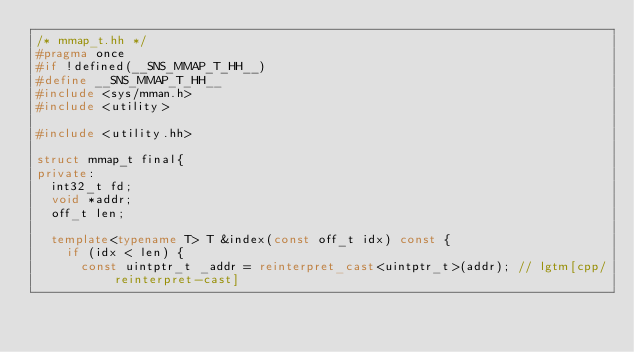<code> <loc_0><loc_0><loc_500><loc_500><_C++_>/* mmap_t.hh */
#pragma once
#if !defined(__SNS_MMAP_T_HH__)
#define __SNS_MMAP_T_HH__
#include <sys/mman.h>
#include <utility>

#include <utility.hh>

struct mmap_t final{
private:
	int32_t fd;
	void *addr;
	off_t len;

	template<typename T> T &index(const off_t idx) const {
		if (idx < len) {
			const uintptr_t _addr = reinterpret_cast<uintptr_t>(addr); // lgtm[cpp/reinterpret-cast]</code> 